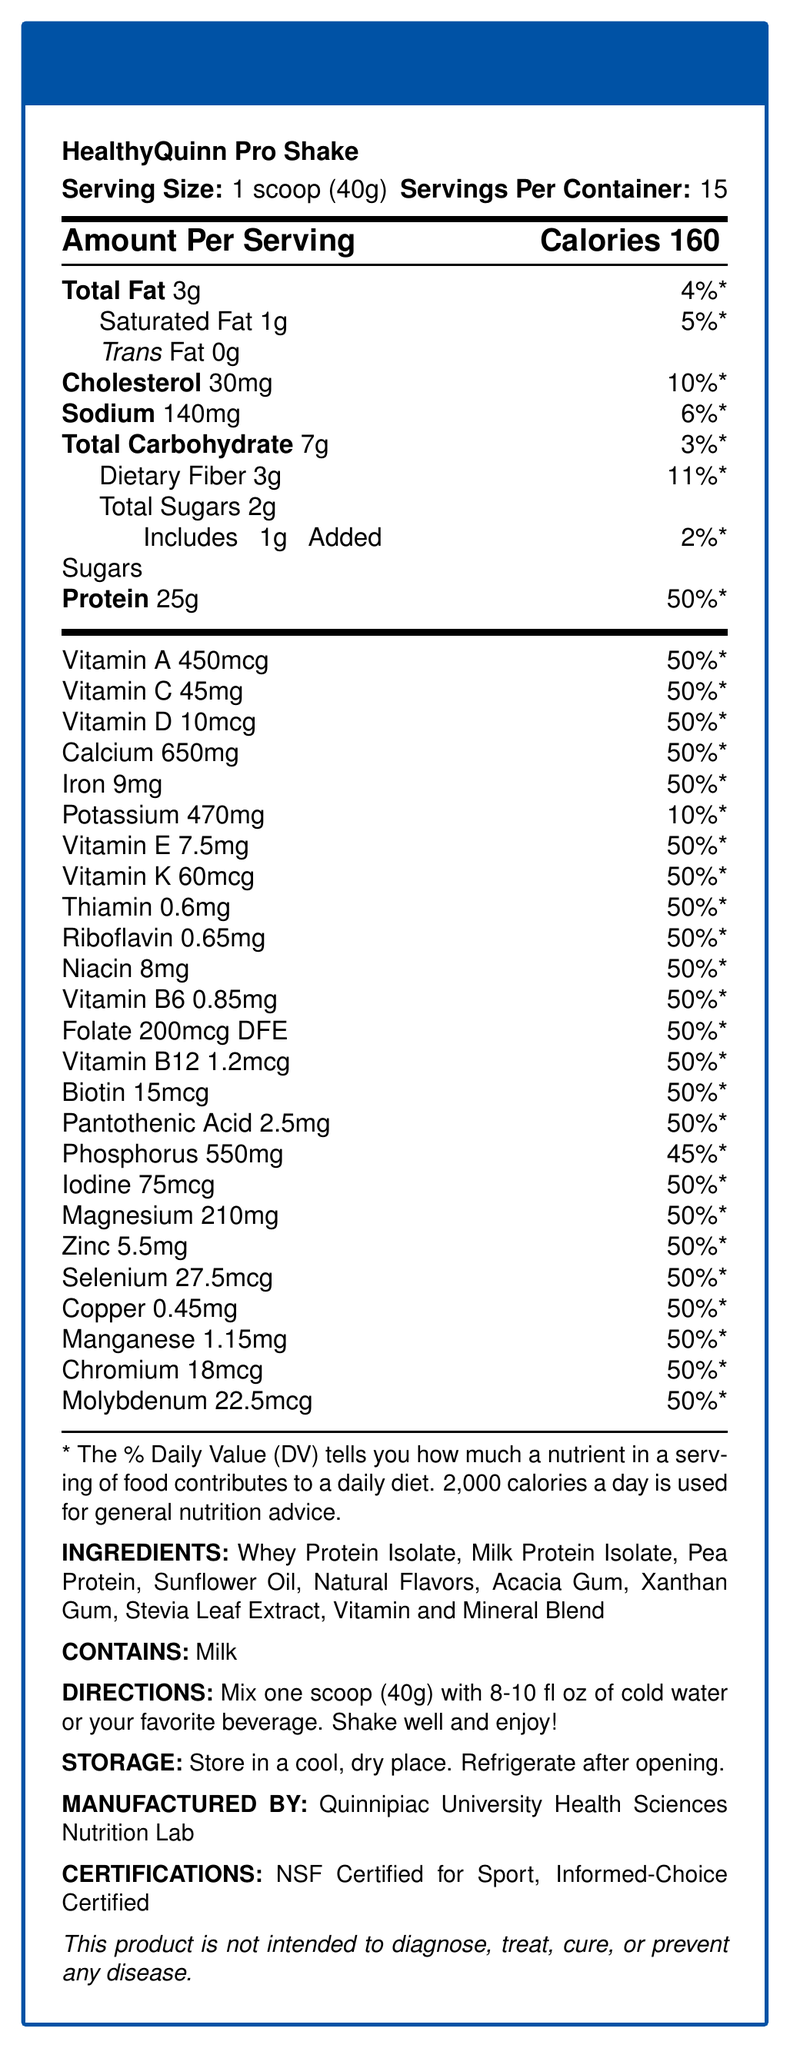what is the serving size? The serving size is explicitly listed as "1 scoop (40g)" in the document.
Answer: 1 scoop (40g) how many calories are in one serving? The document states that each serving contains 160 calories.
Answer: 160 what vitamins and minerals are found in 50% of the recommended daily value in a single serving? The document lists these vitamins and minerals each with a 50% daily value per serving.
Answer: Vitamin A, Vitamin C, Vitamin D, Calcium, Iron, Vitamin E, Vitamin K, Thiamin, Riboflavin, Niacin, Vitamin B6, Folate, Vitamin B12, Biotin, Pantothenic Acid, Iodine, Magnesium, Zinc, Selenium, Copper, Manganese, Chromium, Molybdenum how should this product be stored? The storage instructions are given in the document and state to keep it in a cool, dry place and refrigerate after opening.
Answer: Store in a cool, dry place. Refrigerate after opening. who manufactures this product? The manufacturer is specified as Quinnipiac University Health Sciences Nutrition Lab.
Answer: Quinnipiac University Health Sciences Nutrition Lab The protein content per serving is:  
A. 20g  
B. 25g  
C. 30g The document shows that each serving contains 25 grams of protein.
Answer: B which of the following is not an ingredient:  
1. Whey Protein Isolate  
2. Milk Protein Isolate  
3. Soy Protein  
4. Pea Protein Soy Protein is not listed among the ingredients in the document.
Answer: 3 is this product NSF Certified for Sport? The document lists "NSF Certified for Sport" under certifications.
Answer: Yes what allergens are listed in this product? The document explicitly states that the product contains milk under allergens.
Answer: Milk describe the main idea of the document. The document focuses on presenting comprehensive information about the "HealthyQuinn Pro Shake," detailing its nutritional profile, ingredients, and relevant usage and storage instructions.
Answer: The document provides the nutrition facts, ingredients, allergens, directions for use, storage instructions, manufacturer details, and certifications for the "HealthyQuinn Pro Shake," a high-protein meal replacement shake with added vitamins and minerals. how many servings are in each container? The document mentions that there are 15 servings per container.
Answer: 15 what percent of daily value of potassium does one serving provide? The document lists 470mg of potassium, contributing to 10% of the daily value.
Answer: 10% can this product be used to diagnose, treat, cure, or prevent any disease? The disclaimer clearly states that the product is not intended to diagnose, treat, cure, or prevent any disease.
Answer: No which vitamin is included in an amount of 7.5mg per serving? The document lists Vitamin E as 7.5mg per serving.
Answer: Vitamin E what is the total amount of sugars per serving, including added sugars? The document mentions total sugars as 2g per serving, with 1g being added sugars.
Answer: 2g (1g added sugars) how many calories are derived from fat in one serving? The document specifies the total fat content but does not provide information on the calories specifically derived from fat.
Answer: Cannot be determined 